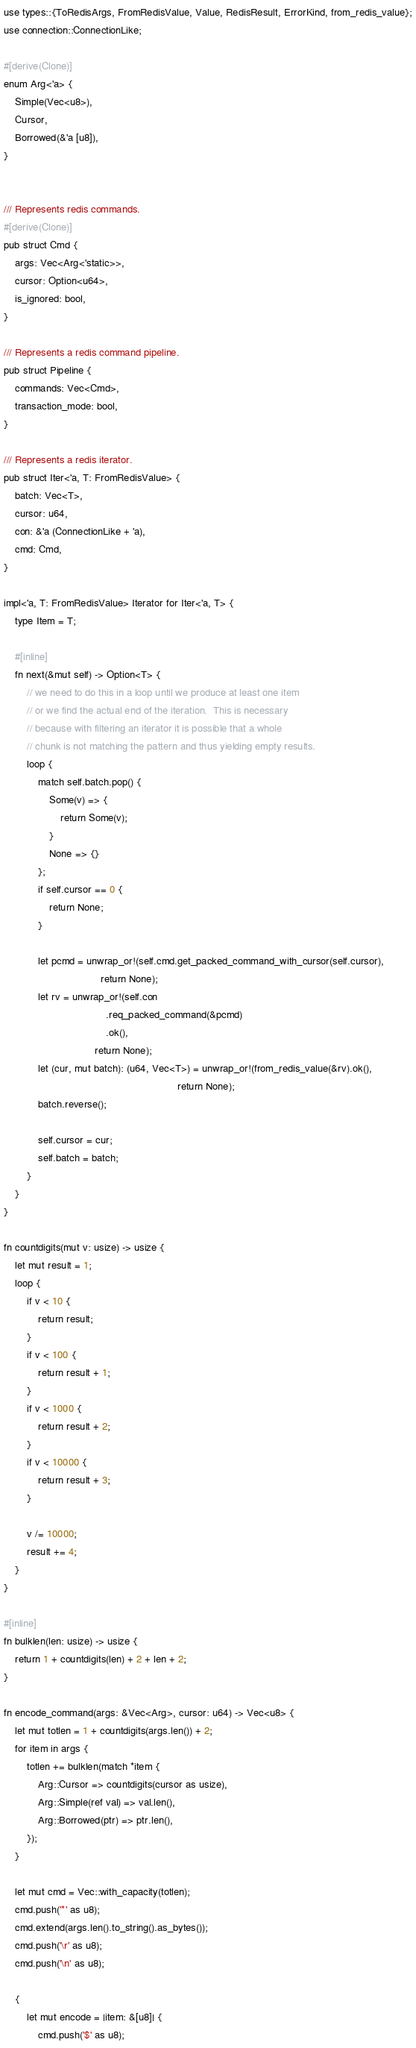<code> <loc_0><loc_0><loc_500><loc_500><_Rust_>use types::{ToRedisArgs, FromRedisValue, Value, RedisResult, ErrorKind, from_redis_value};
use connection::ConnectionLike;

#[derive(Clone)]
enum Arg<'a> {
    Simple(Vec<u8>),
    Cursor,
    Borrowed(&'a [u8]),
}


/// Represents redis commands.
#[derive(Clone)]
pub struct Cmd {
    args: Vec<Arg<'static>>,
    cursor: Option<u64>,
    is_ignored: bool,
}

/// Represents a redis command pipeline.
pub struct Pipeline {
    commands: Vec<Cmd>,
    transaction_mode: bool,
}

/// Represents a redis iterator.
pub struct Iter<'a, T: FromRedisValue> {
    batch: Vec<T>,
    cursor: u64,
    con: &'a (ConnectionLike + 'a),
    cmd: Cmd,
}

impl<'a, T: FromRedisValue> Iterator for Iter<'a, T> {
    type Item = T;

    #[inline]
    fn next(&mut self) -> Option<T> {
        // we need to do this in a loop until we produce at least one item
        // or we find the actual end of the iteration.  This is necessary
        // because with filtering an iterator it is possible that a whole
        // chunk is not matching the pattern and thus yielding empty results.
        loop {
            match self.batch.pop() {
                Some(v) => {
                    return Some(v);
                }
                None => {}
            };
            if self.cursor == 0 {
                return None;
            }

            let pcmd = unwrap_or!(self.cmd.get_packed_command_with_cursor(self.cursor),
                                  return None);
            let rv = unwrap_or!(self.con
                                    .req_packed_command(&pcmd)
                                    .ok(),
                                return None);
            let (cur, mut batch): (u64, Vec<T>) = unwrap_or!(from_redis_value(&rv).ok(),
                                                             return None);
            batch.reverse();

            self.cursor = cur;
            self.batch = batch;
        }
    }
}

fn countdigits(mut v: usize) -> usize {
    let mut result = 1;
    loop {
        if v < 10 {
            return result;
        }
        if v < 100 {
            return result + 1;
        }
        if v < 1000 {
            return result + 2;
        }
        if v < 10000 {
            return result + 3;
        }

        v /= 10000;
        result += 4;
    }
}

#[inline]
fn bulklen(len: usize) -> usize {
    return 1 + countdigits(len) + 2 + len + 2;
}

fn encode_command(args: &Vec<Arg>, cursor: u64) -> Vec<u8> {
    let mut totlen = 1 + countdigits(args.len()) + 2;
    for item in args {
        totlen += bulklen(match *item {
            Arg::Cursor => countdigits(cursor as usize),
            Arg::Simple(ref val) => val.len(),
            Arg::Borrowed(ptr) => ptr.len(),
        });
    }

    let mut cmd = Vec::with_capacity(totlen);
    cmd.push('*' as u8);
    cmd.extend(args.len().to_string().as_bytes());
    cmd.push('\r' as u8);
    cmd.push('\n' as u8);

    {
        let mut encode = |item: &[u8]| {
            cmd.push('$' as u8);</code> 